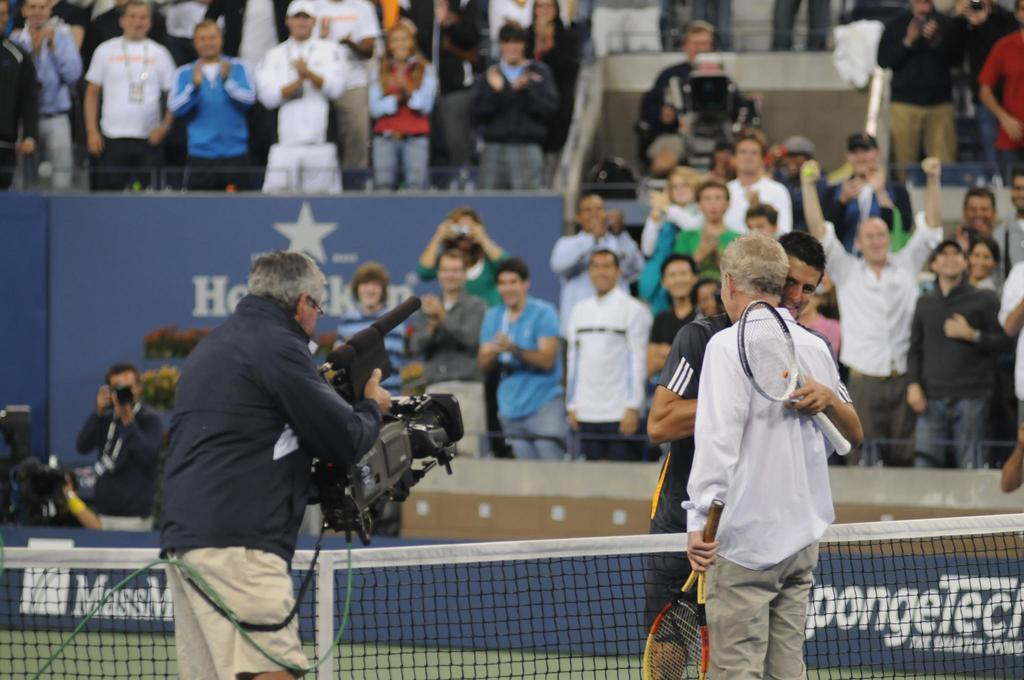<image>
Give a short and clear explanation of the subsequent image. Tennis players converge at center court near a banner that reads Spongetech. 